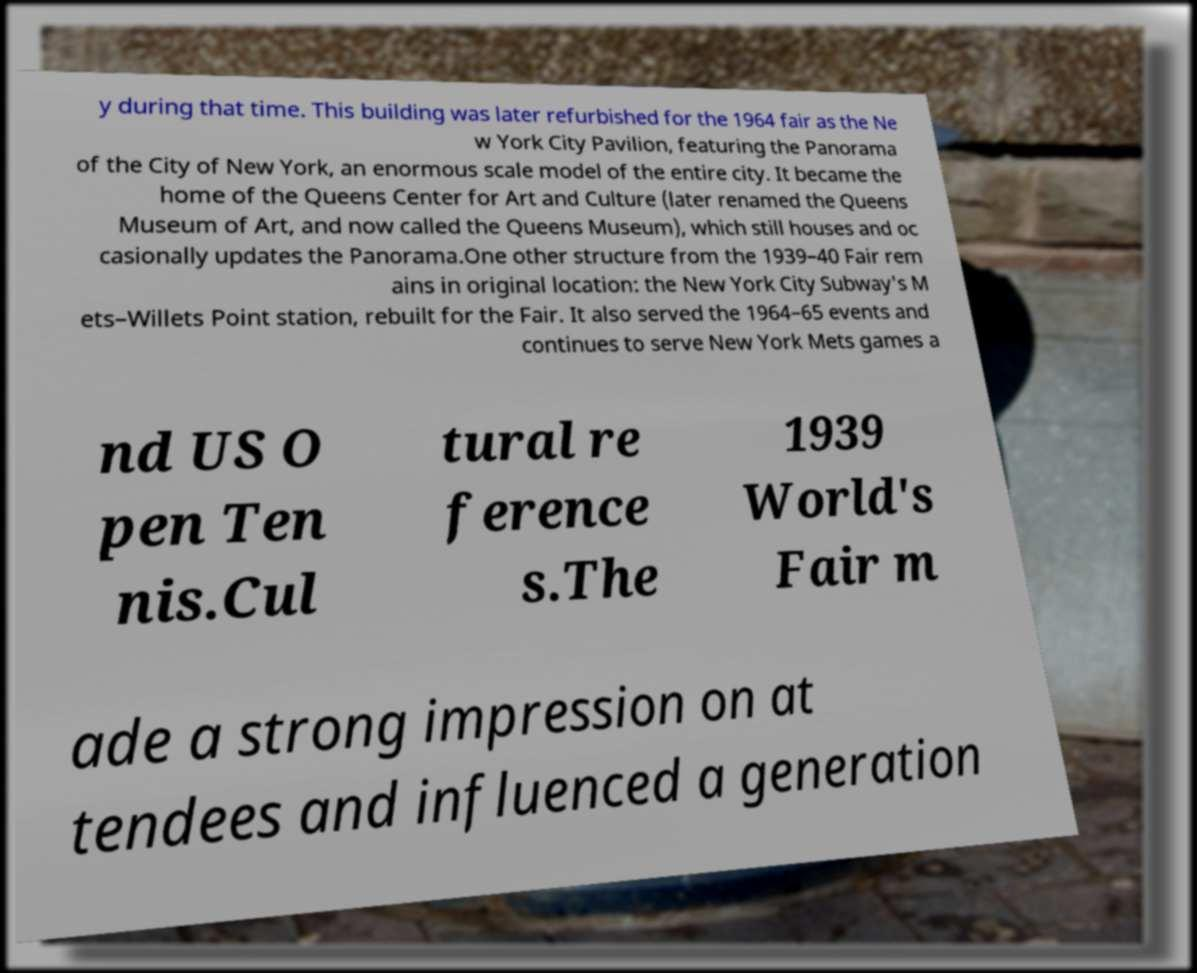There's text embedded in this image that I need extracted. Can you transcribe it verbatim? y during that time. This building was later refurbished for the 1964 fair as the Ne w York City Pavilion, featuring the Panorama of the City of New York, an enormous scale model of the entire city. It became the home of the Queens Center for Art and Culture (later renamed the Queens Museum of Art, and now called the Queens Museum), which still houses and oc casionally updates the Panorama.One other structure from the 1939–40 Fair rem ains in original location: the New York City Subway's M ets–Willets Point station, rebuilt for the Fair. It also served the 1964–65 events and continues to serve New York Mets games a nd US O pen Ten nis.Cul tural re ference s.The 1939 World's Fair m ade a strong impression on at tendees and influenced a generation 